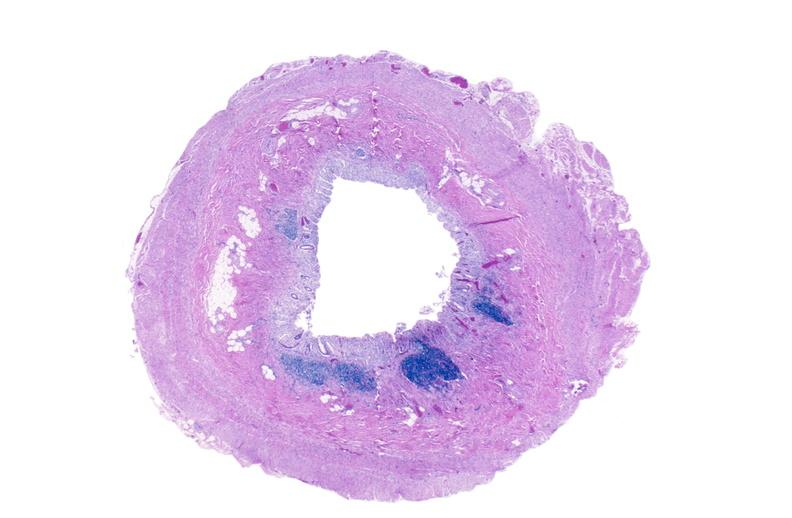what does this image show?
Answer the question using a single word or phrase. Normal appendix 